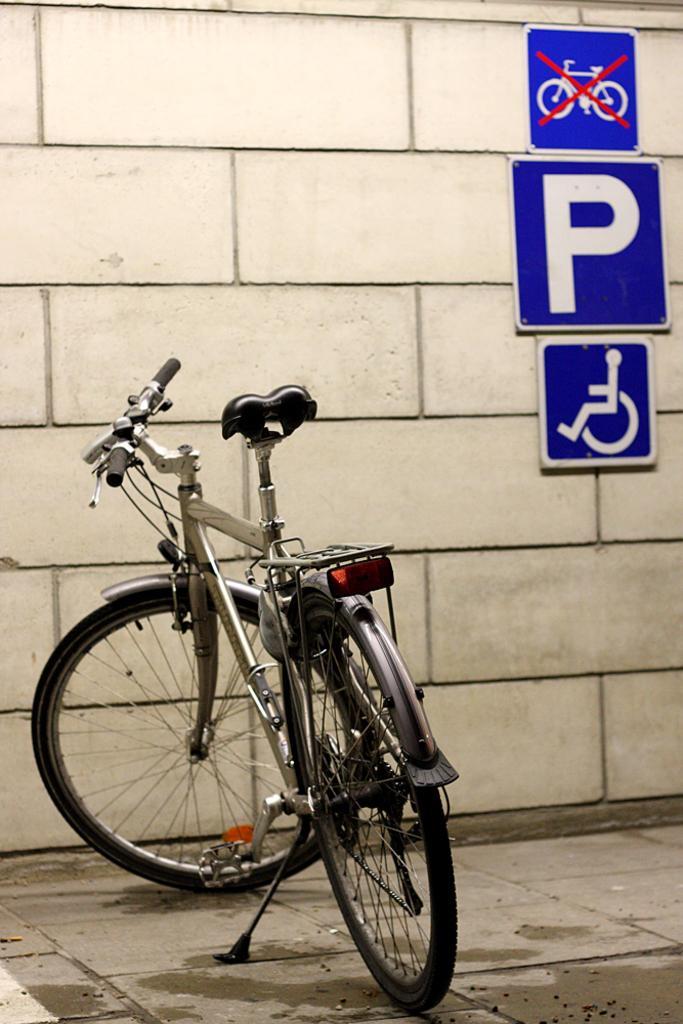Can you describe this image briefly? In the image in the center we can see cycle. In the background there is a wall and sign boards. 